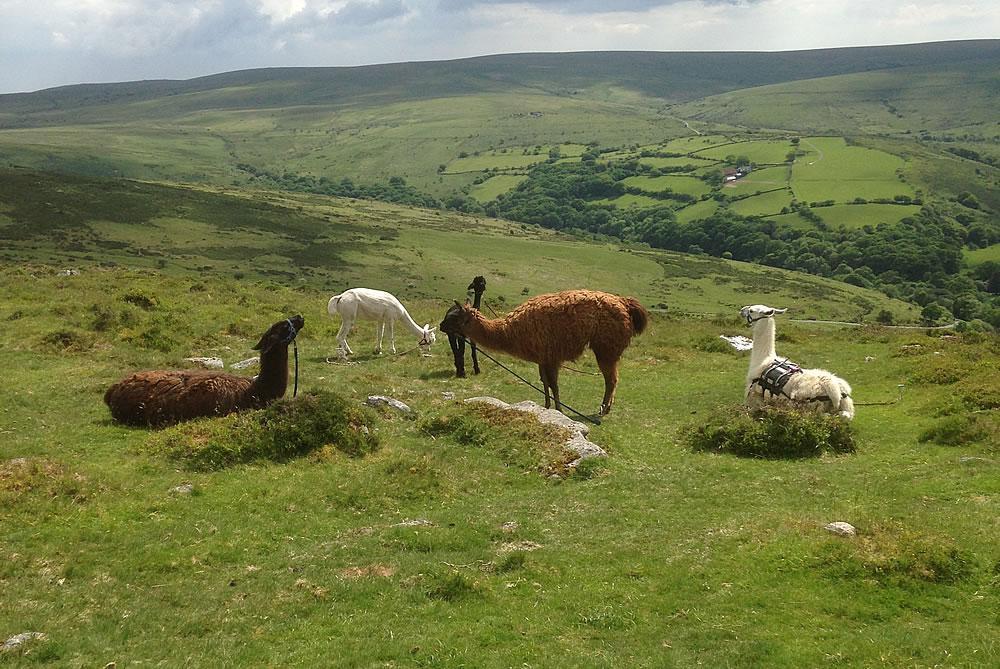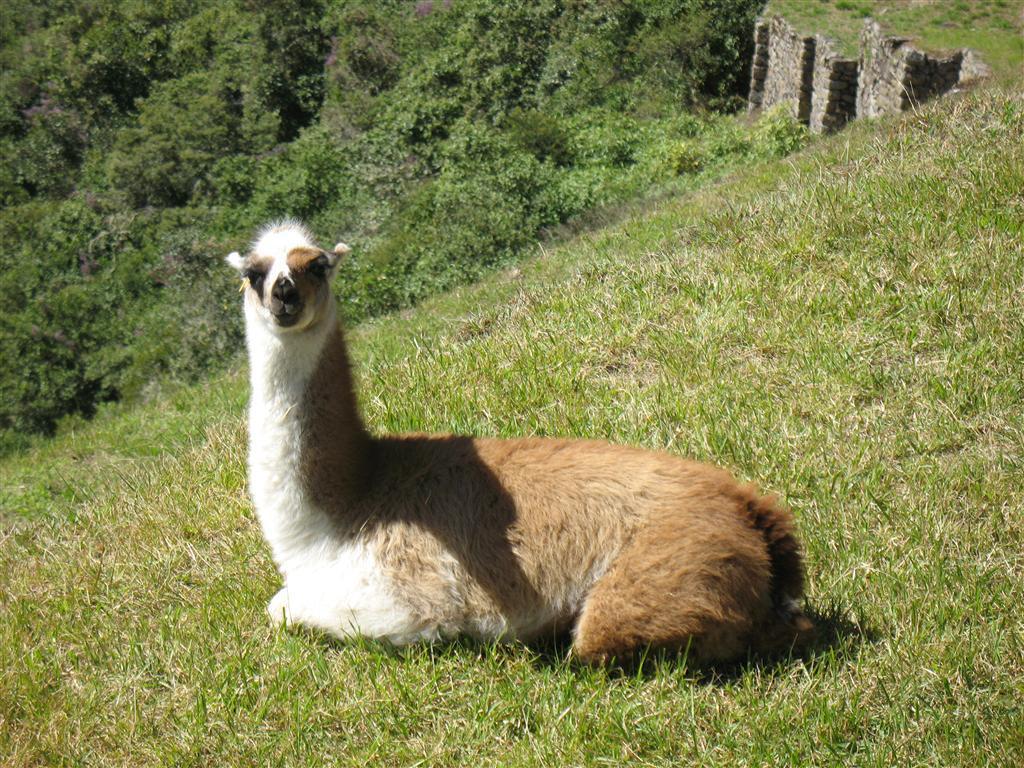The first image is the image on the left, the second image is the image on the right. Analyze the images presented: Is the assertion "The right image contains one llama reclining with its body aimed leftward and its pright head turned forward." valid? Answer yes or no. Yes. The first image is the image on the left, the second image is the image on the right. Analyze the images presented: Is the assertion "The left and right image contains no more than three total llamas." valid? Answer yes or no. No. 